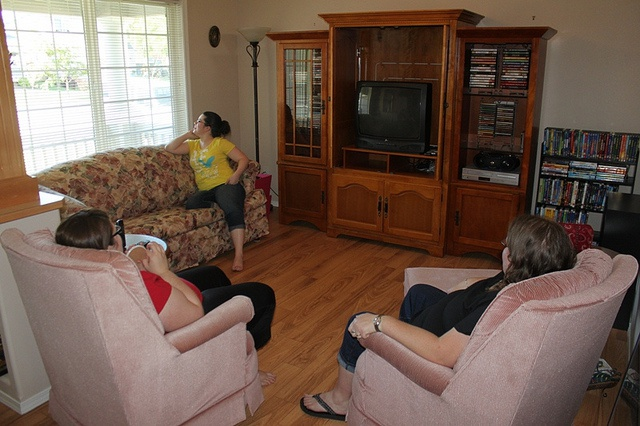Describe the objects in this image and their specific colors. I can see chair in gray and darkgray tones, chair in gray and darkgray tones, couch in gray and maroon tones, people in gray, black, and tan tones, and people in gray, black, and brown tones in this image. 